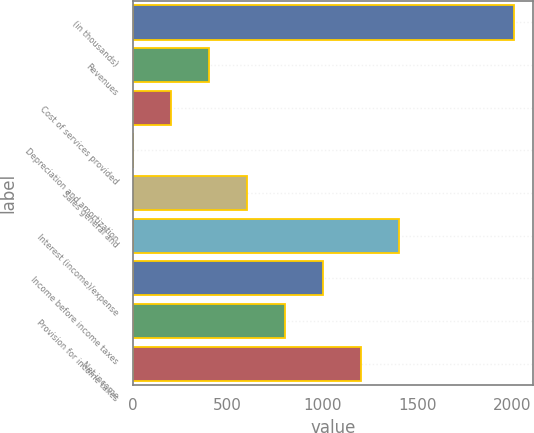Convert chart to OTSL. <chart><loc_0><loc_0><loc_500><loc_500><bar_chart><fcel>(in thousands)<fcel>Revenues<fcel>Cost of services provided<fcel>Depreciation and amortization<fcel>Sales general and<fcel>Interest (income)/expense<fcel>Income before income taxes<fcel>Provision for income taxes<fcel>Net income<nl><fcel>2007<fcel>402.04<fcel>201.42<fcel>0.8<fcel>602.66<fcel>1405.14<fcel>1003.9<fcel>803.28<fcel>1204.52<nl></chart> 